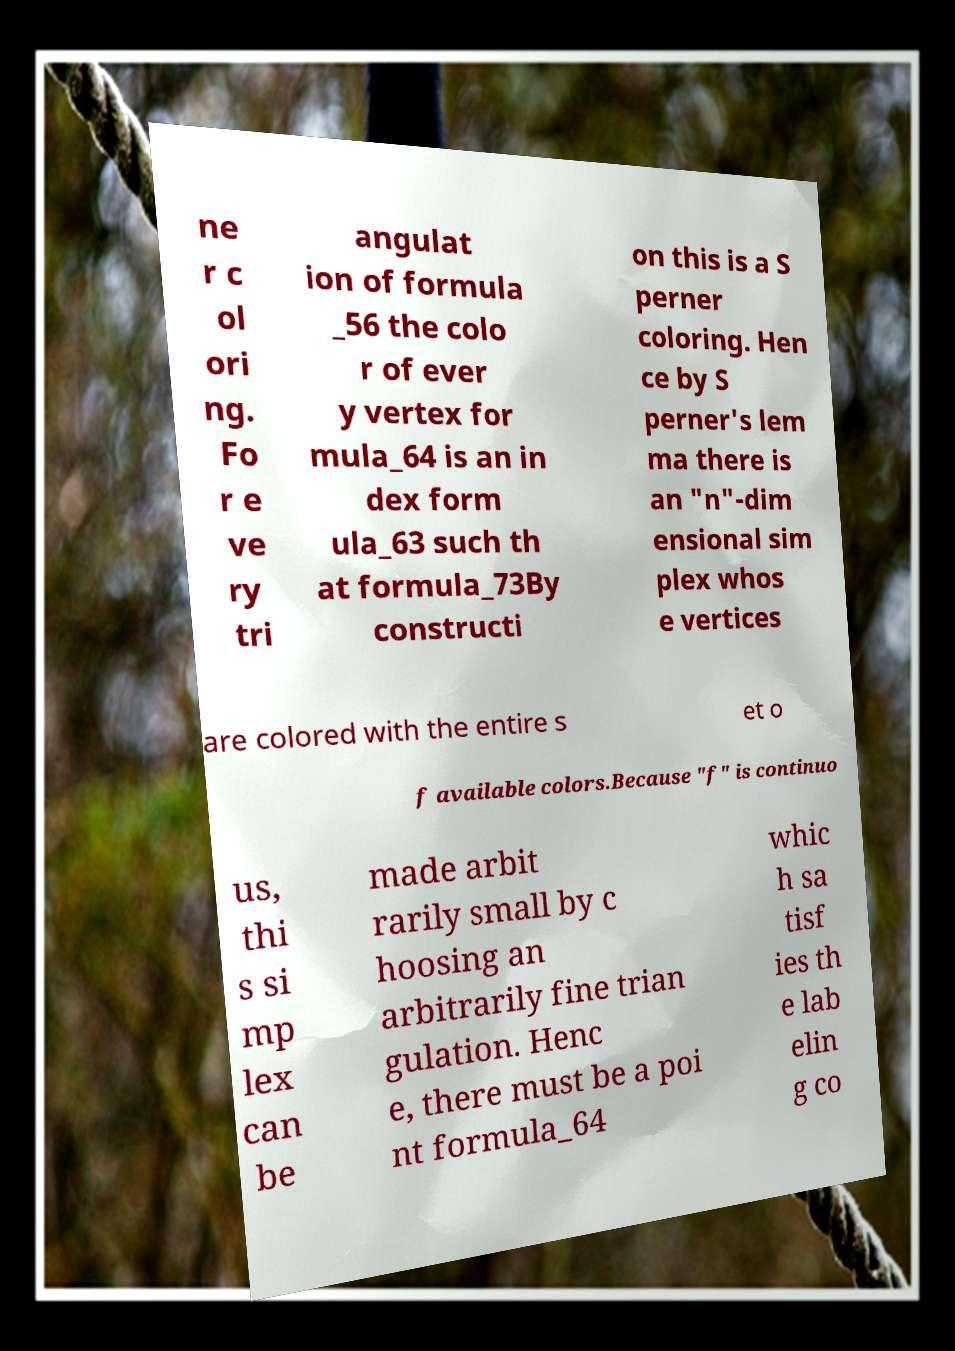Can you read and provide the text displayed in the image?This photo seems to have some interesting text. Can you extract and type it out for me? ne r c ol ori ng. Fo r e ve ry tri angulat ion of formula _56 the colo r of ever y vertex for mula_64 is an in dex form ula_63 such th at formula_73By constructi on this is a S perner coloring. Hen ce by S perner's lem ma there is an "n"-dim ensional sim plex whos e vertices are colored with the entire s et o f available colors.Because "f" is continuo us, thi s si mp lex can be made arbit rarily small by c hoosing an arbitrarily fine trian gulation. Henc e, there must be a poi nt formula_64 whic h sa tisf ies th e lab elin g co 